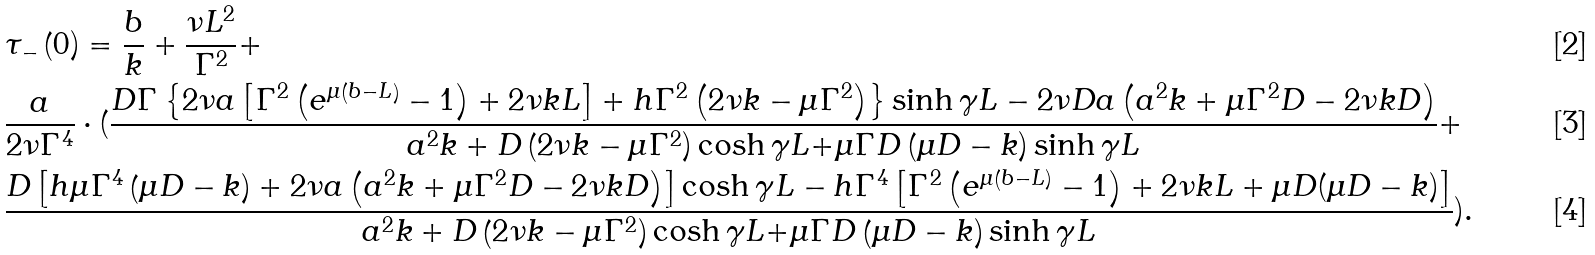Convert formula to latex. <formula><loc_0><loc_0><loc_500><loc_500>& \tau _ { - } \left ( 0 \right ) = \frac { b } { k } + \frac { \nu L ^ { 2 } } { \Gamma ^ { 2 } } + \\ & \frac { a } { 2 \nu \Gamma ^ { 4 } } \cdot ( \frac { D \Gamma \left \{ 2 \nu a \left [ \Gamma ^ { 2 } \left ( e ^ { \mu \left ( b - L \right ) } - 1 \right ) + 2 \nu k L \right ] + h \Gamma ^ { 2 } \left ( 2 \nu k - \mu \Gamma ^ { 2 } \right ) \right \} \sinh { \gamma L } - 2 \nu D a \left ( a ^ { 2 } k + \mu \Gamma ^ { 2 } D - 2 \nu k D \right ) } { a ^ { 2 } k + D \left ( 2 \nu k - \mu \Gamma ^ { 2 } \right ) \cosh { \gamma L + } \mu \Gamma D \left ( \mu D - k \right ) \sinh { \gamma L } } + \\ & \frac { D \left [ h \mu \Gamma ^ { 4 } \left ( \mu D - k \right ) + 2 \nu a \left ( a ^ { 2 } k + \mu \Gamma ^ { 2 } D - 2 \nu k D \right ) \right ] \cosh { \gamma L } - h \Gamma ^ { 4 } \left [ \Gamma ^ { 2 } \left ( e ^ { \mu \left ( b - L \right ) } - 1 \right ) + 2 \nu k L + \mu D ( \mu D - k ) \right ] } { a ^ { 2 } k + D \left ( 2 \nu k - \mu \Gamma ^ { 2 } \right ) \cosh { \gamma L + } \mu \Gamma D \left ( \mu D - k \right ) \sinh { \gamma L } } ) .</formula> 